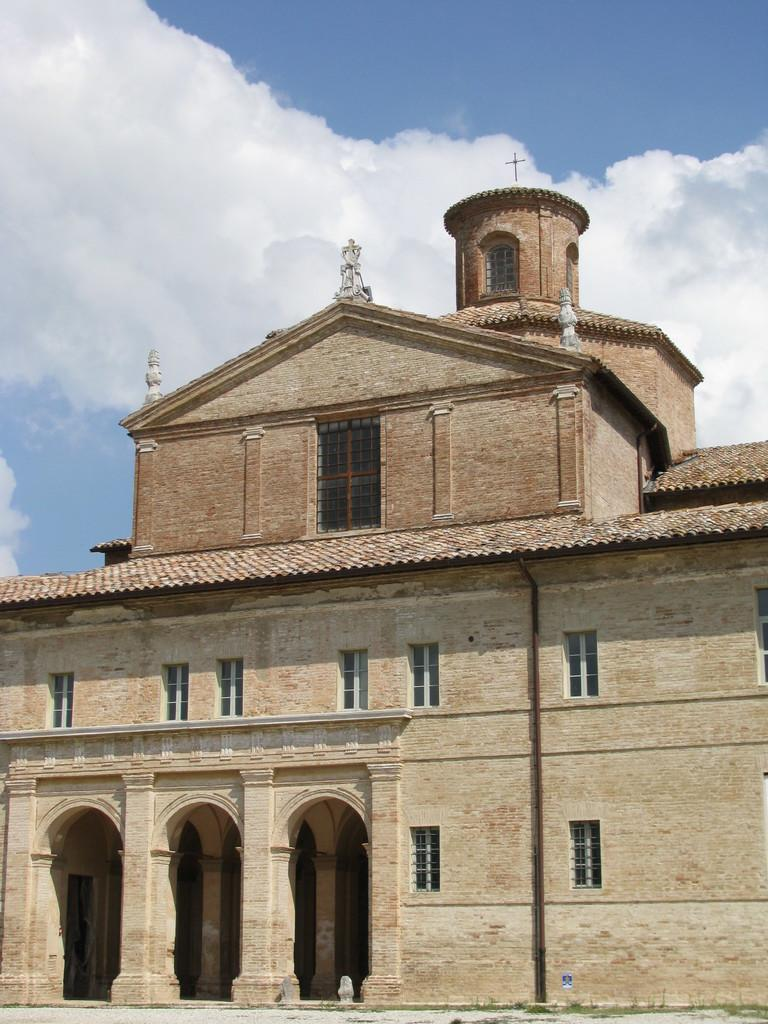What is the main subject of the picture? There is a monument in the picture. What architectural features can be seen in the picture? Windows are visible in the picture. What can be seen in the background of the picture? The sky is visible in the picture, and clouds are present in the sky. Can you describe any symbols or markings in the picture? There is a cross mark in the picture. What type of cake is being served on the plate in the picture? There is no cake or plate present in the picture; it features a monument with windows and a cross mark. 